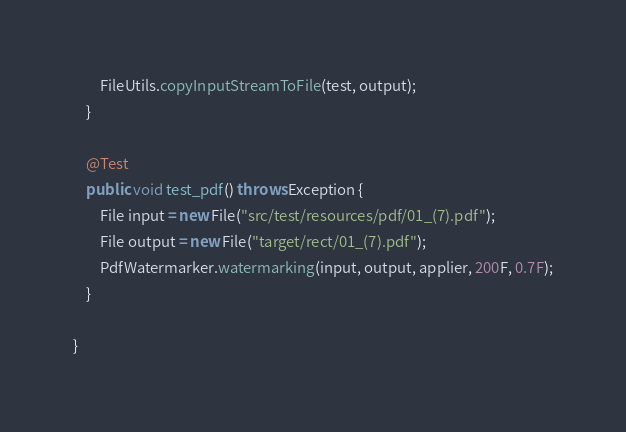Convert code to text. <code><loc_0><loc_0><loc_500><loc_500><_Java_>        FileUtils.copyInputStreamToFile(test, output);
    }

    @Test
    public void test_pdf() throws Exception {
        File input = new File("src/test/resources/pdf/01_(7).pdf");
        File output = new File("target/rect/01_(7).pdf");
        PdfWatermarker.watermarking(input, output, applier, 200F, 0.7F);
    }

}
</code> 